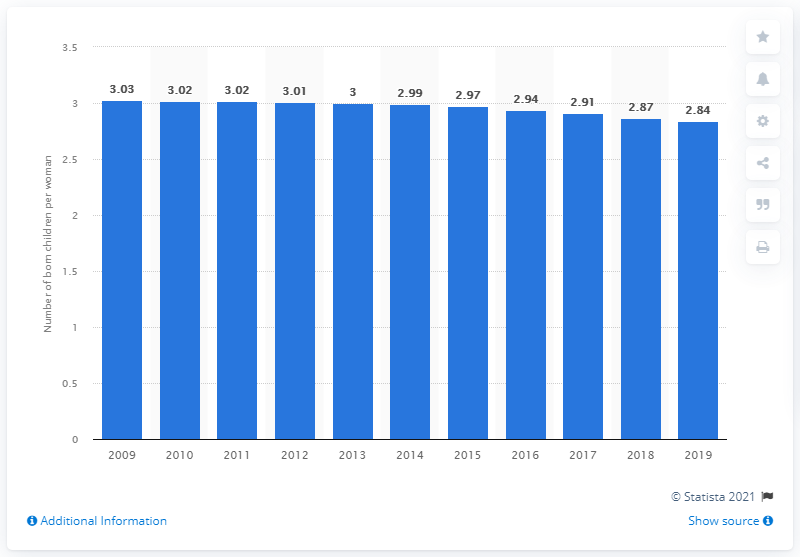Give some essential details in this illustration. In 2019, the fertility rate in Botswana was 2.84. 